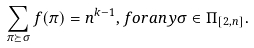Convert formula to latex. <formula><loc_0><loc_0><loc_500><loc_500>\sum _ { \pi \succeq \sigma } f ( \pi ) = n ^ { k - 1 } , f o r a n y \sigma \in \Pi _ { [ 2 , n ] } .</formula> 